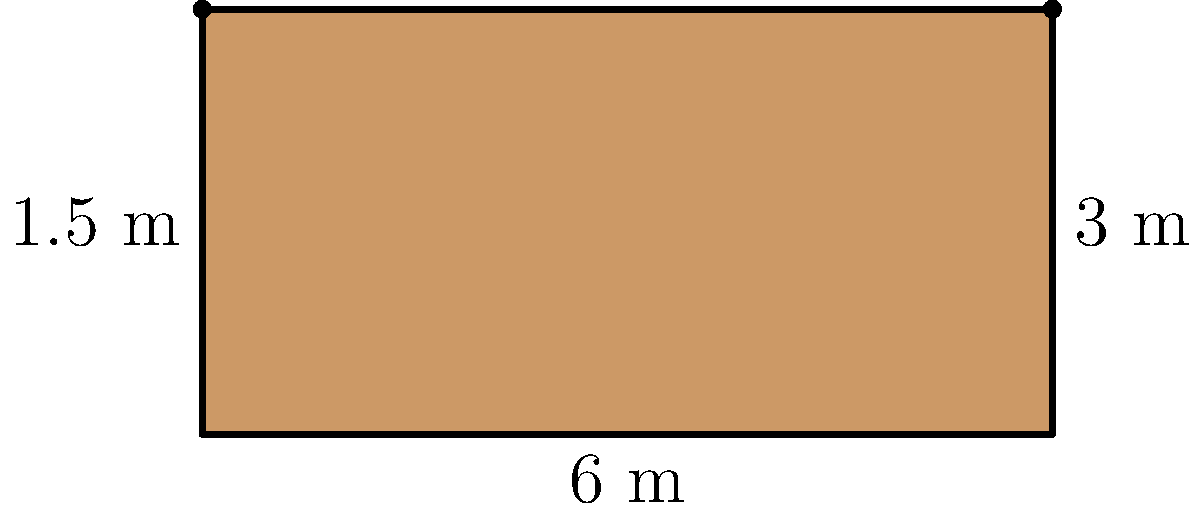You're planning to outdo your rival by installing a luxurious bar counter. The counter is rectangular with a semicircular end, as shown in the diagram. The straight portion is 6 meters long and 3 meters wide, while the radius of the semicircular end is 1.5 meters. Calculate the total area of the bar counter in square meters. To find the total area, we need to calculate the areas of the rectangular part and the semicircular part separately, then add them together.

1. Area of the rectangle:
   $A_{rectangle} = length \times width$
   $A_{rectangle} = 6 \text{ m} \times 3 \text{ m} = 18 \text{ m}^2$

2. Area of the semicircle:
   $A_{semicircle} = \frac{1}{2} \times \pi r^2$
   $A_{semicircle} = \frac{1}{2} \times \pi \times (1.5 \text{ m})^2$
   $A_{semicircle} = \frac{1}{2} \times \pi \times 2.25 \text{ m}^2 \approx 3.53 \text{ m}^2$

3. Total area:
   $A_{total} = A_{rectangle} + A_{semicircle}$
   $A_{total} = 18 \text{ m}^2 + 3.53 \text{ m}^2 = 21.53 \text{ m}^2$

Rounding to two decimal places, the total area is 21.53 square meters.
Answer: 21.53 m² 